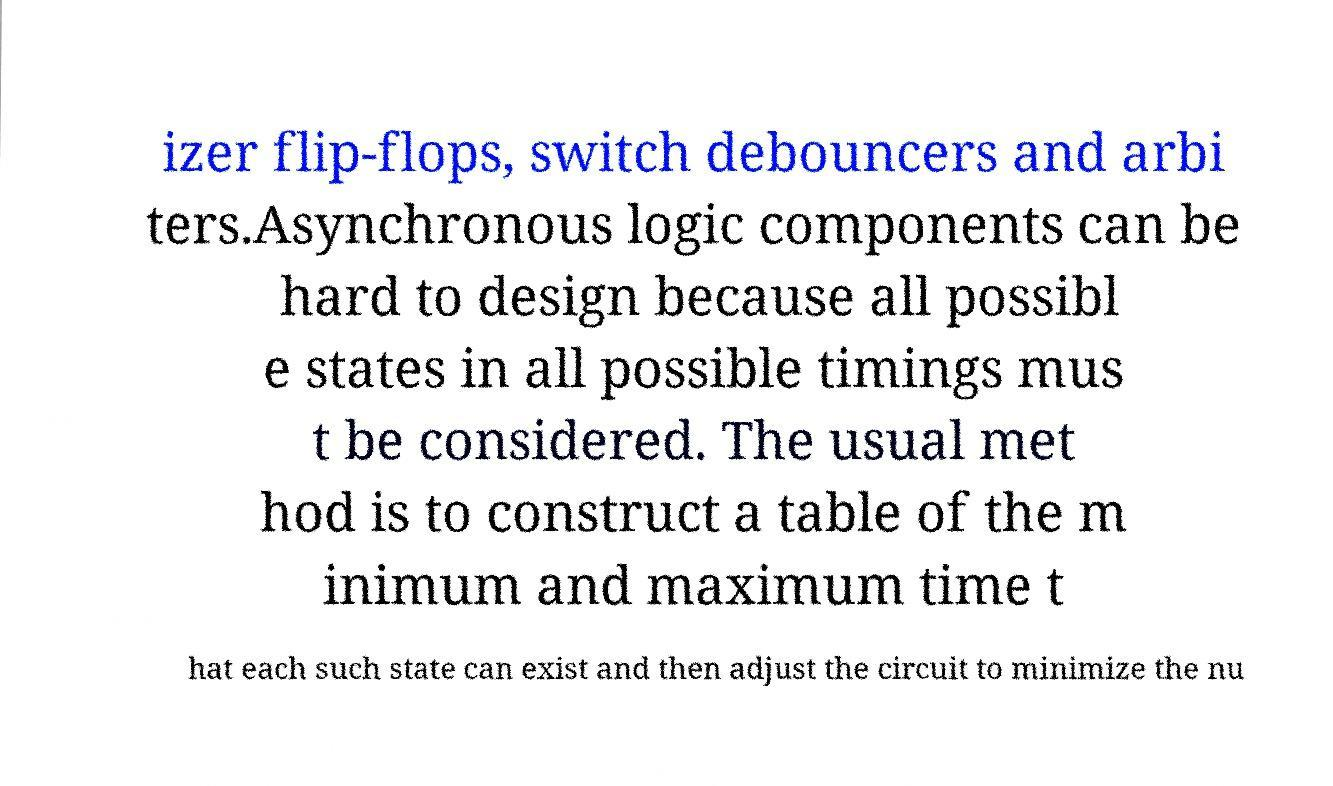What messages or text are displayed in this image? I need them in a readable, typed format. izer flip-flops, switch debouncers and arbi ters.Asynchronous logic components can be hard to design because all possibl e states in all possible timings mus t be considered. The usual met hod is to construct a table of the m inimum and maximum time t hat each such state can exist and then adjust the circuit to minimize the nu 